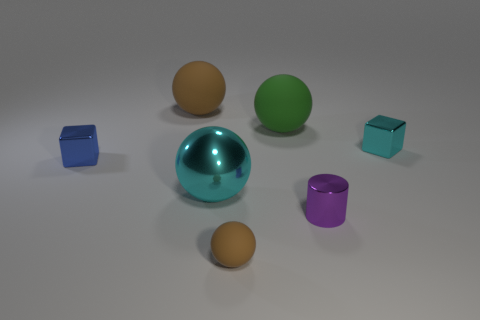What is the size of the cyan metal ball?
Give a very brief answer. Large. There is a tiny blue object; does it have the same shape as the cyan shiny thing behind the large cyan metallic thing?
Make the answer very short. Yes. The small thing that is made of the same material as the green sphere is what color?
Keep it short and to the point. Brown. How big is the purple cylinder that is behind the small brown ball?
Keep it short and to the point. Small. Are there fewer large metallic things that are behind the small blue thing than tiny blocks?
Give a very brief answer. Yes. Is there anything else that has the same shape as the small purple metallic object?
Offer a terse response. No. Is the number of tiny things less than the number of things?
Ensure brevity in your answer.  Yes. The big ball that is in front of the small cube to the right of the big green sphere is what color?
Offer a very short reply. Cyan. There is a tiny cube on the right side of the brown rubber sphere in front of the cyan object that is on the right side of the big green matte ball; what is its material?
Provide a short and direct response. Metal. There is a block left of the cyan sphere; is it the same size as the metallic sphere?
Your answer should be compact. No. 